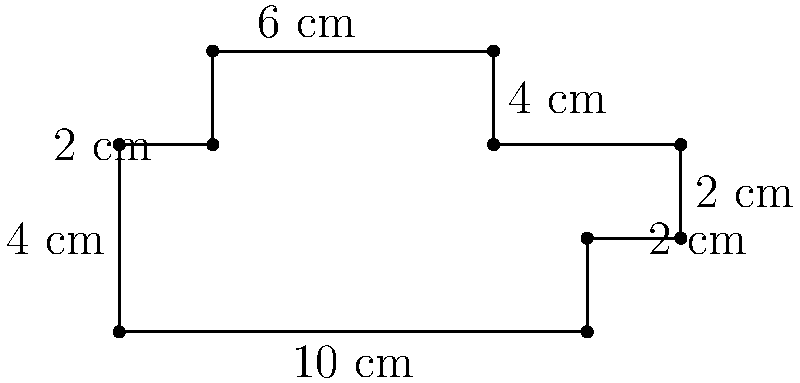You are designing a custom mixing console for a studio. The top view of the console has an irregular shape as shown in the diagram. Calculate the perimeter of the mixing console in centimeters. To find the perimeter of the irregularly shaped mixing console, we need to sum up the lengths of all sides:

1. Bottom edge: 10 cm
2. Right bottom edge: 2 cm
3. Right middle edge: 2 cm
4. Right top edge: 2 cm
5. Top right edge: 4 cm
6. Top edge: 6 cm
7. Top left edge: 2 cm
8. Left top edge: 2 cm
9. Left bottom edge: 4 cm

Now, let's add all these lengths:

$$10 + 2 + 2 + 2 + 4 + 6 + 2 + 2 + 4 = 34 \text{ cm}$$

Therefore, the perimeter of the mixing console is 34 cm.
Answer: 34 cm 